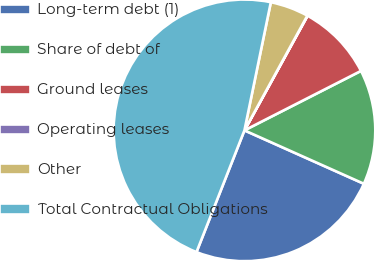Convert chart to OTSL. <chart><loc_0><loc_0><loc_500><loc_500><pie_chart><fcel>Long-term debt (1)<fcel>Share of debt of<fcel>Ground leases<fcel>Operating leases<fcel>Other<fcel>Total Contractual Obligations<nl><fcel>24.28%<fcel>14.2%<fcel>9.48%<fcel>0.03%<fcel>4.75%<fcel>47.26%<nl></chart> 